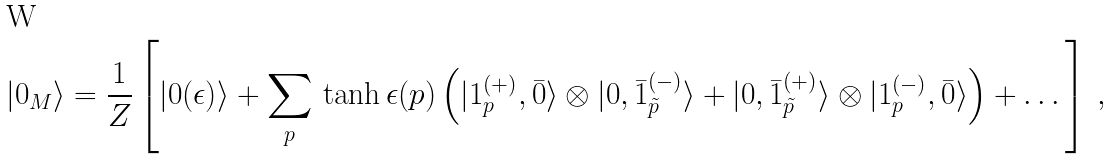Convert formula to latex. <formula><loc_0><loc_0><loc_500><loc_500>| 0 _ { M } \rangle = \frac { 1 } { Z } \left [ | 0 ( \epsilon ) \rangle + \sum _ { p } \, \tanh \epsilon ( p ) \left ( | 1 ^ { ( + ) } _ { p } , \bar { 0 } \rangle \otimes | 0 , \bar { 1 } ^ { ( - ) } _ { \tilde { p } } \rangle + | 0 , \bar { 1 } ^ { ( + ) } _ { \tilde { p } } \rangle \otimes | 1 ^ { ( - ) } _ { p } , \bar { 0 } \rangle \right ) + \dots \right ] \, ,</formula> 